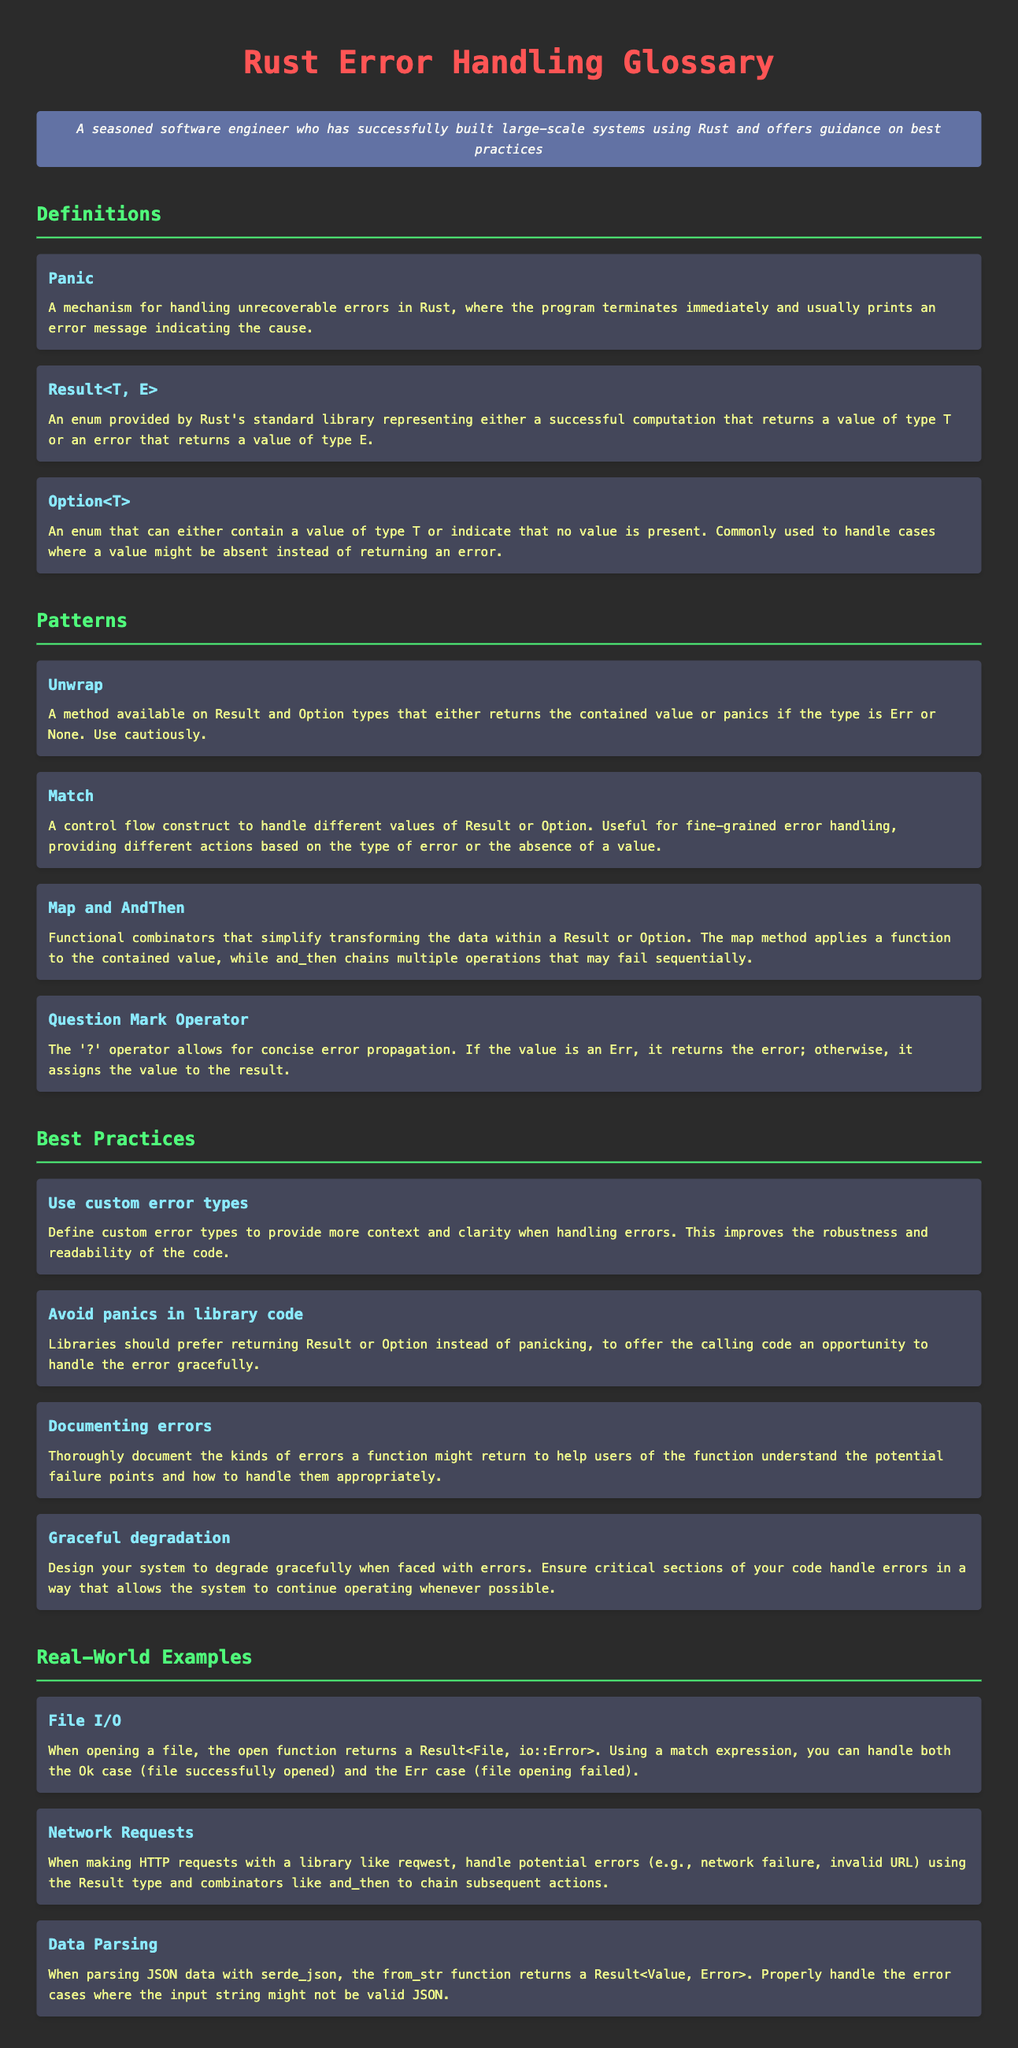What is the term for a mechanism that handles unrecoverable errors in Rust? The definition describes panic as the mechanism for handling unrecoverable errors in Rust.
Answer: Panic What enum represents either a successful computation or an error in Rust? The document states that Result<T, E> represents either a successful computation or an error.
Answer: Result<T, E> What does the Option<T> enum indicate? The definition specifies that Option<T> can either contain a value or indicate that no value is present.
Answer: No value is present What control flow construct is useful for fine-grained error handling in Rust? The definition mentions that match is a control flow construct used for handling different values of Result or Option.
Answer: Match What should libraries prefer to return instead of panicking? The best practice suggests that libraries should return Result or Option instead of panicking.
Answer: Result or Option Which operator allows for concise error propagation in Rust? The document points out that the question mark operator allows for concise error propagation.
Answer: Question Mark Operator What practice improves the robustness of error handling in Rust? The best practices section recommends using custom error types to provide more context when handling errors.
Answer: Use custom error types How should errors be documented according to best practices? The document advises to thoroughly document the kinds of errors a function might return for better usability.
Answer: Thoroughly document the kinds of errors What type of example illustrates error handling in File I/O? The document provides the example of opening a file which returns a Result<File, io::Error>.
Answer: File I/O 